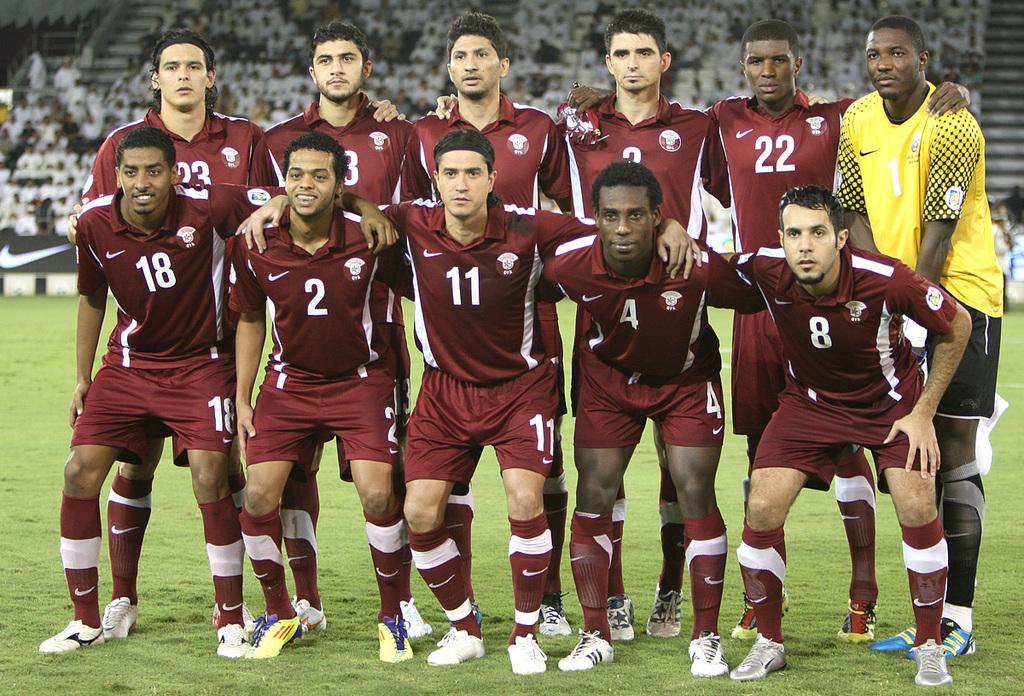<image>
Create a compact narrative representing the image presented. A picture of a soccer team, one is wearing a  read shirt with 11 on it 